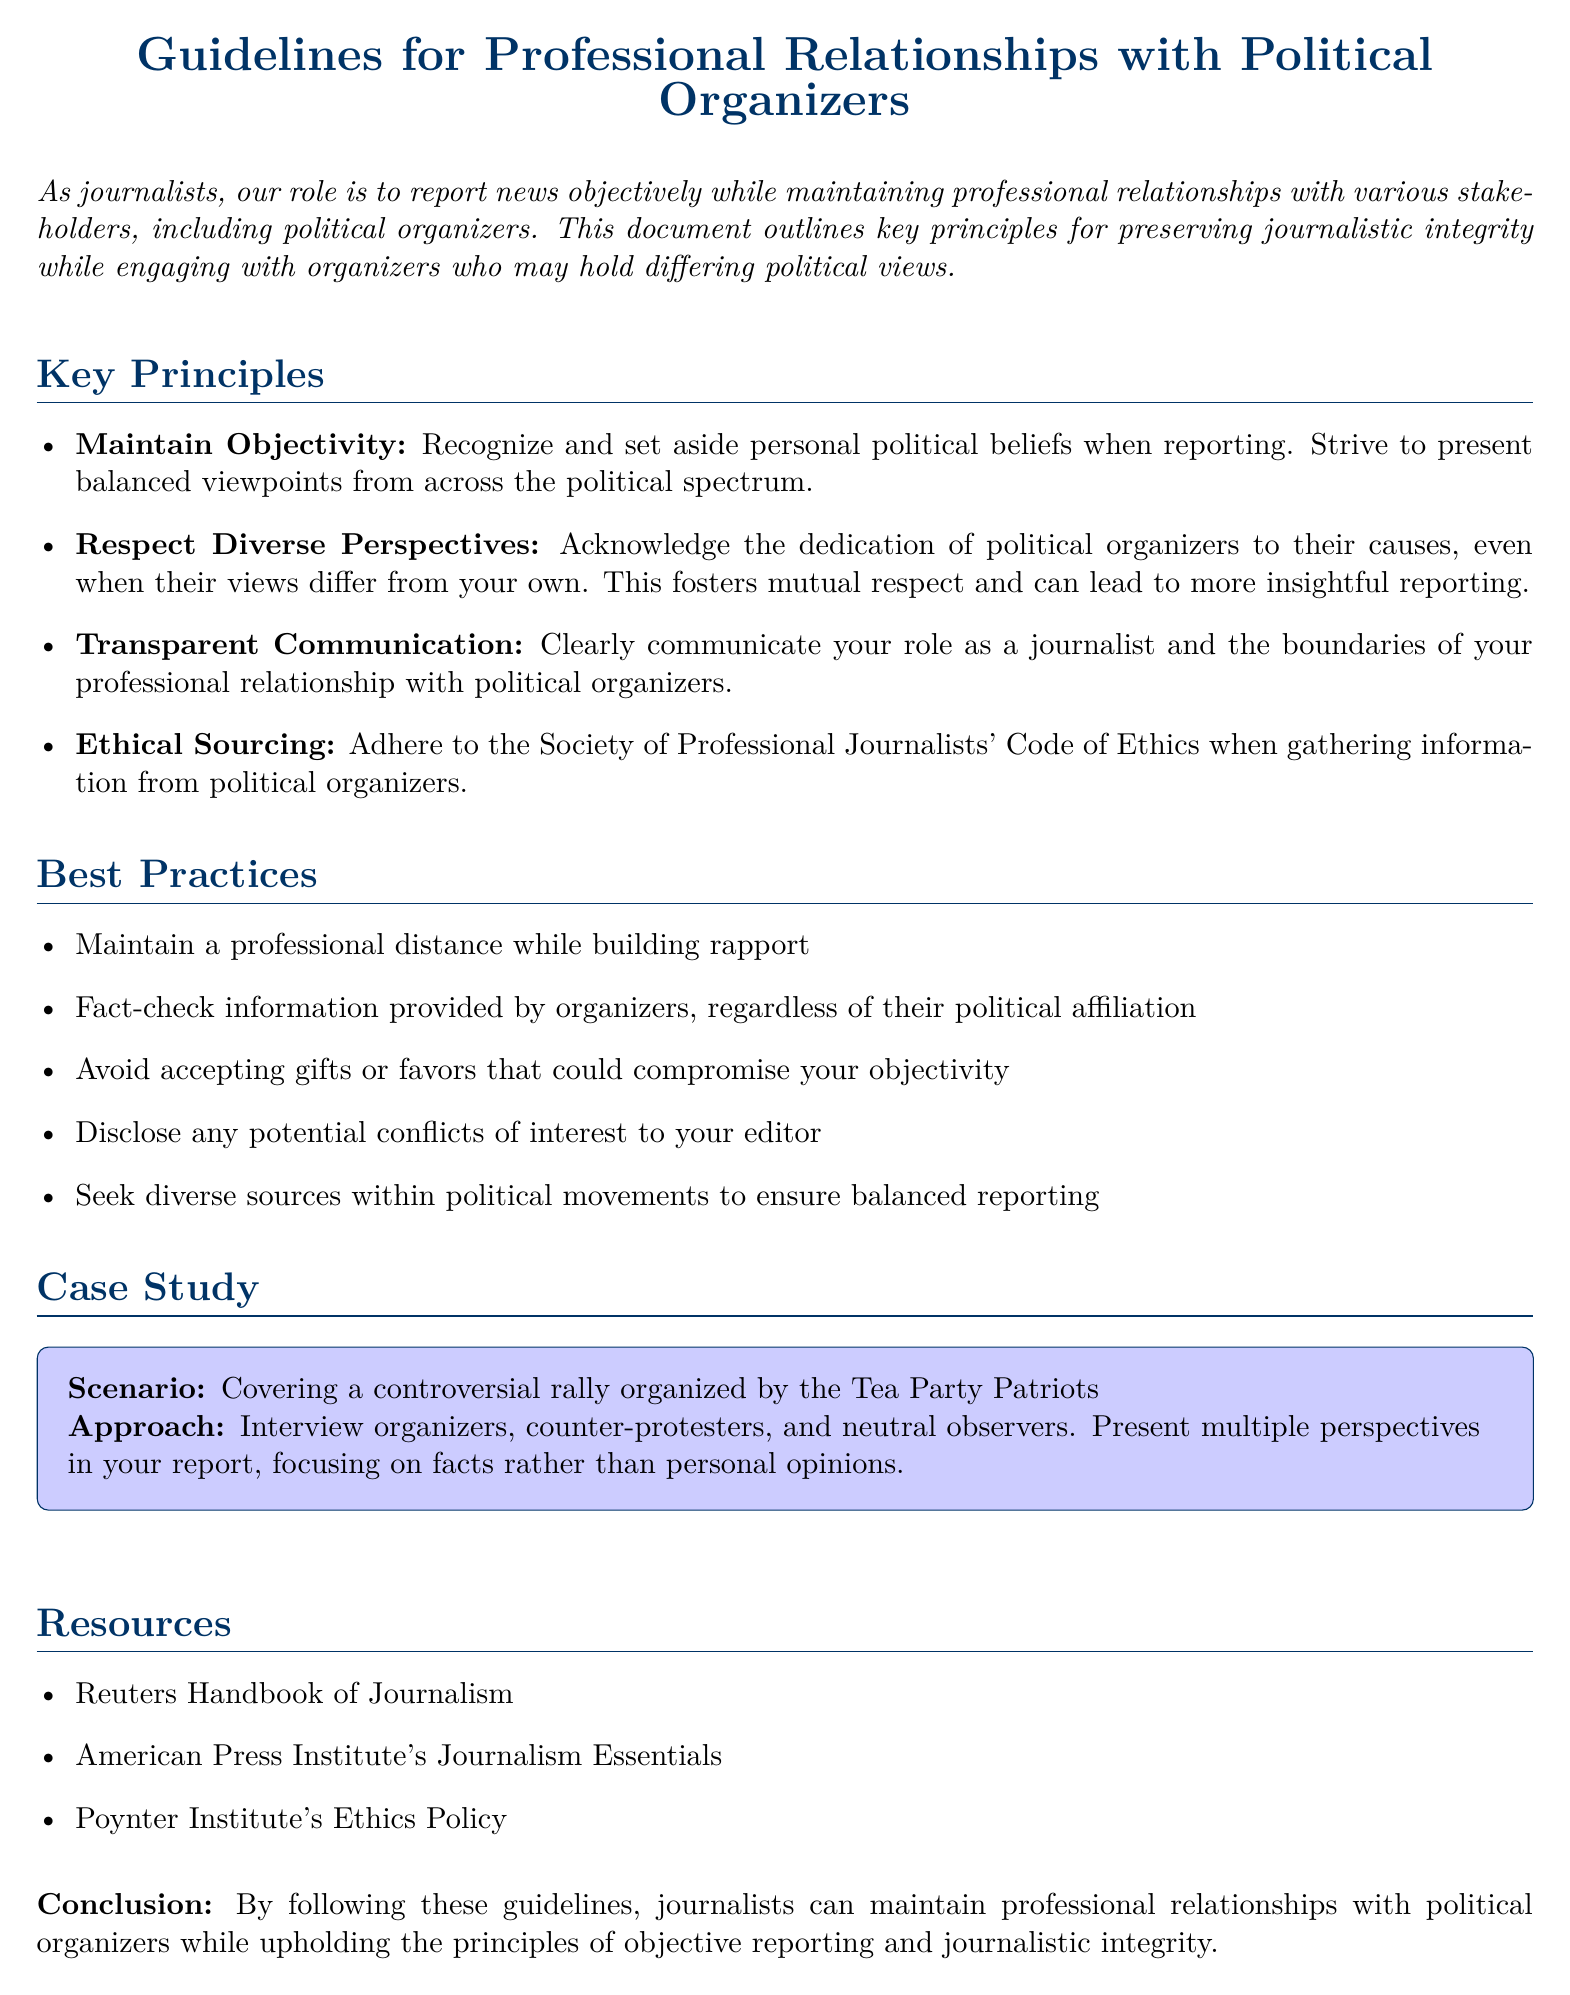what is the title of the document? The title is presented at the beginning of the document, indicating the focus on professional relationships with political organizers.
Answer: Guidelines for Professional Relationships with Political Organizers what is the first key principle mentioned? The first key principle outlined in the document emphasizes the importance of remaining impartial in reporting.
Answer: Maintain Objectivity how many best practices are listed? The number of best practices can be counted from the bullet points in the document.
Answer: Five which organization's code of ethics should journalists adhere to? The document specifies the relevant ethical guideline to follow when gathering information.
Answer: Society of Professional Journalists what is the main focus of the case study included in the document? The case study presents a specific situation that illustrates the guidelines in action regarding a controversial event.
Answer: Covering a controversial rally organized by the Tea Party Patriots what type of communication is emphasized in the best practices? The document highlights a specific aspect of how journalists should interact professionally with political organizers.
Answer: Transparent Communication what resources are suggested for further guidance? The document lists specific resources that journalists can refer to for additional help.
Answer: Reuters Handbook of Journalism what should a journalist do regarding potential conflicts of interest? This principle addresses the journalist's responsibility to disclose specific situations that may affect their reporting.
Answer: Disclose any potential conflicts of interest to your editor 